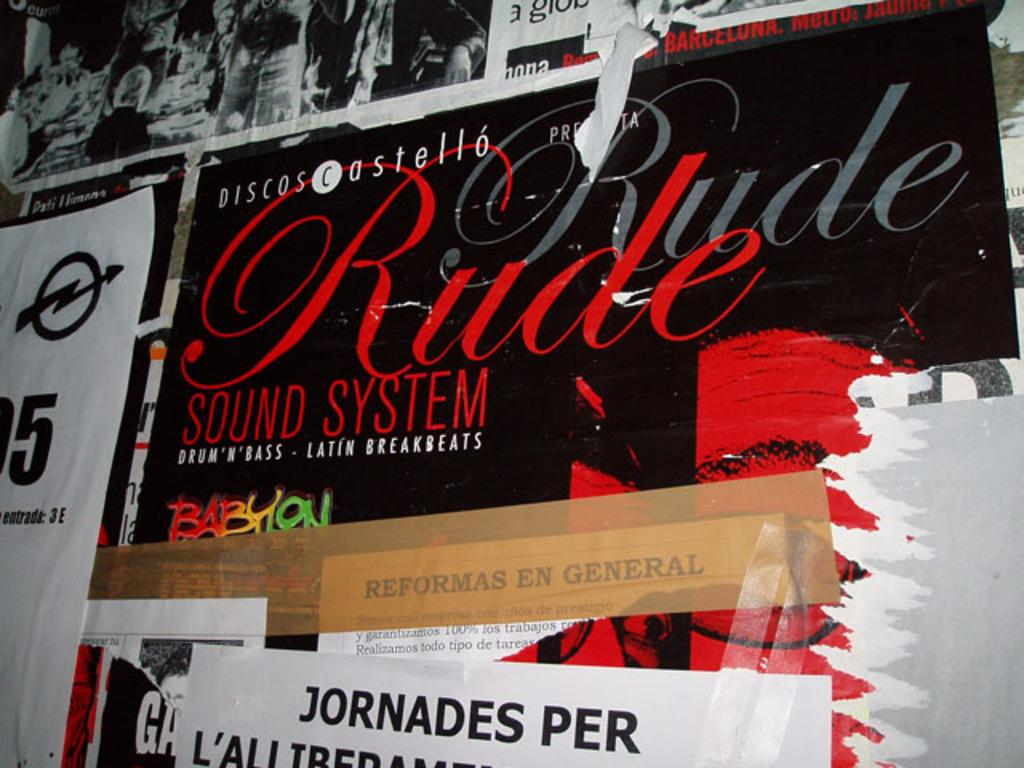<image>
Describe the image concisely. A wall filled with different posters one being Rude Sound System. 